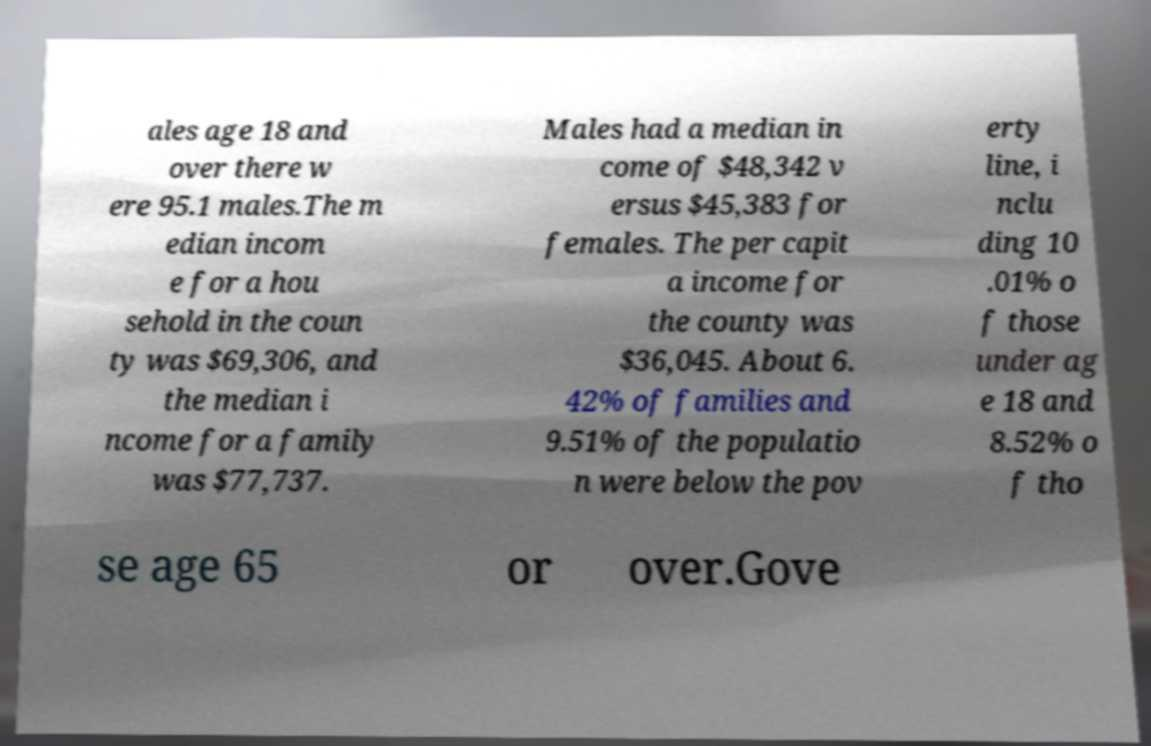Could you extract and type out the text from this image? ales age 18 and over there w ere 95.1 males.The m edian incom e for a hou sehold in the coun ty was $69,306, and the median i ncome for a family was $77,737. Males had a median in come of $48,342 v ersus $45,383 for females. The per capit a income for the county was $36,045. About 6. 42% of families and 9.51% of the populatio n were below the pov erty line, i nclu ding 10 .01% o f those under ag e 18 and 8.52% o f tho se age 65 or over.Gove 